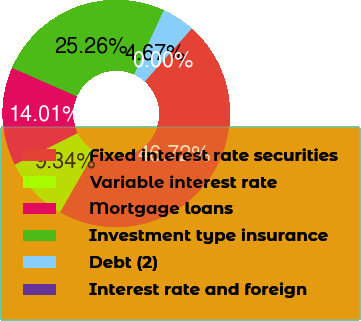<chart> <loc_0><loc_0><loc_500><loc_500><pie_chart><fcel>Fixed interest rate securities<fcel>Variable interest rate<fcel>Mortgage loans<fcel>Investment type insurance<fcel>Debt (2)<fcel>Interest rate and foreign<nl><fcel>46.71%<fcel>9.34%<fcel>14.01%<fcel>25.25%<fcel>4.67%<fcel>0.0%<nl></chart> 